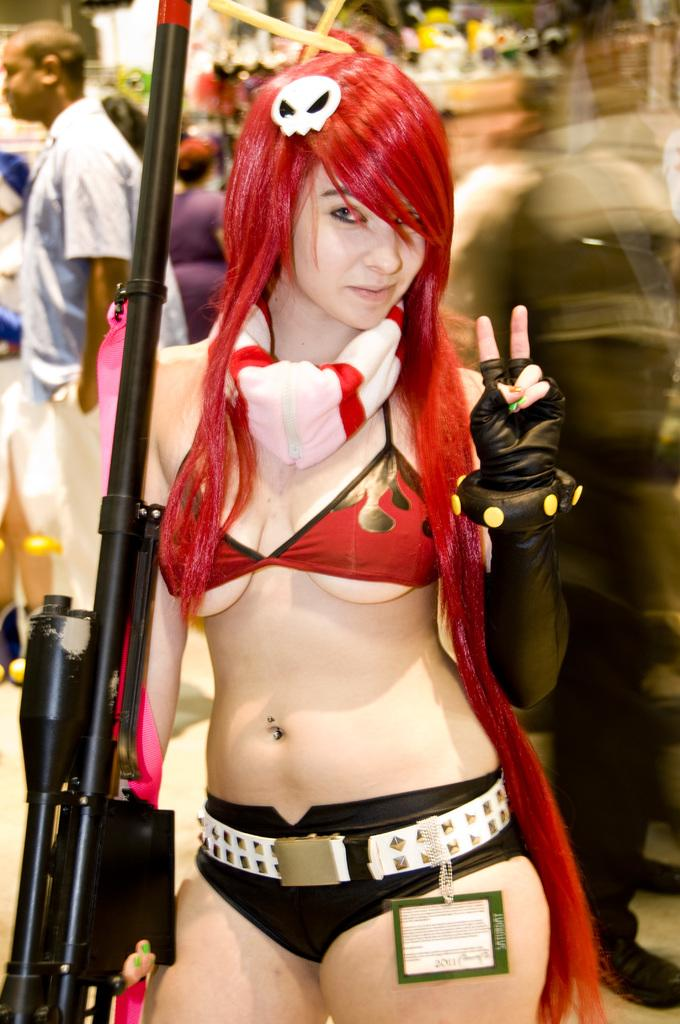Who is the main subject in the image? There is a woman in the image. What is the woman wearing? The woman is wearing a red and black dress. Can you describe the background of the image? There are people standing in the background of the image. How many apples are being recorded by the woman in the image? There are no apples or recordings present in the image. What type of hammer is the woman using in the image? There is no hammer present in the image. 